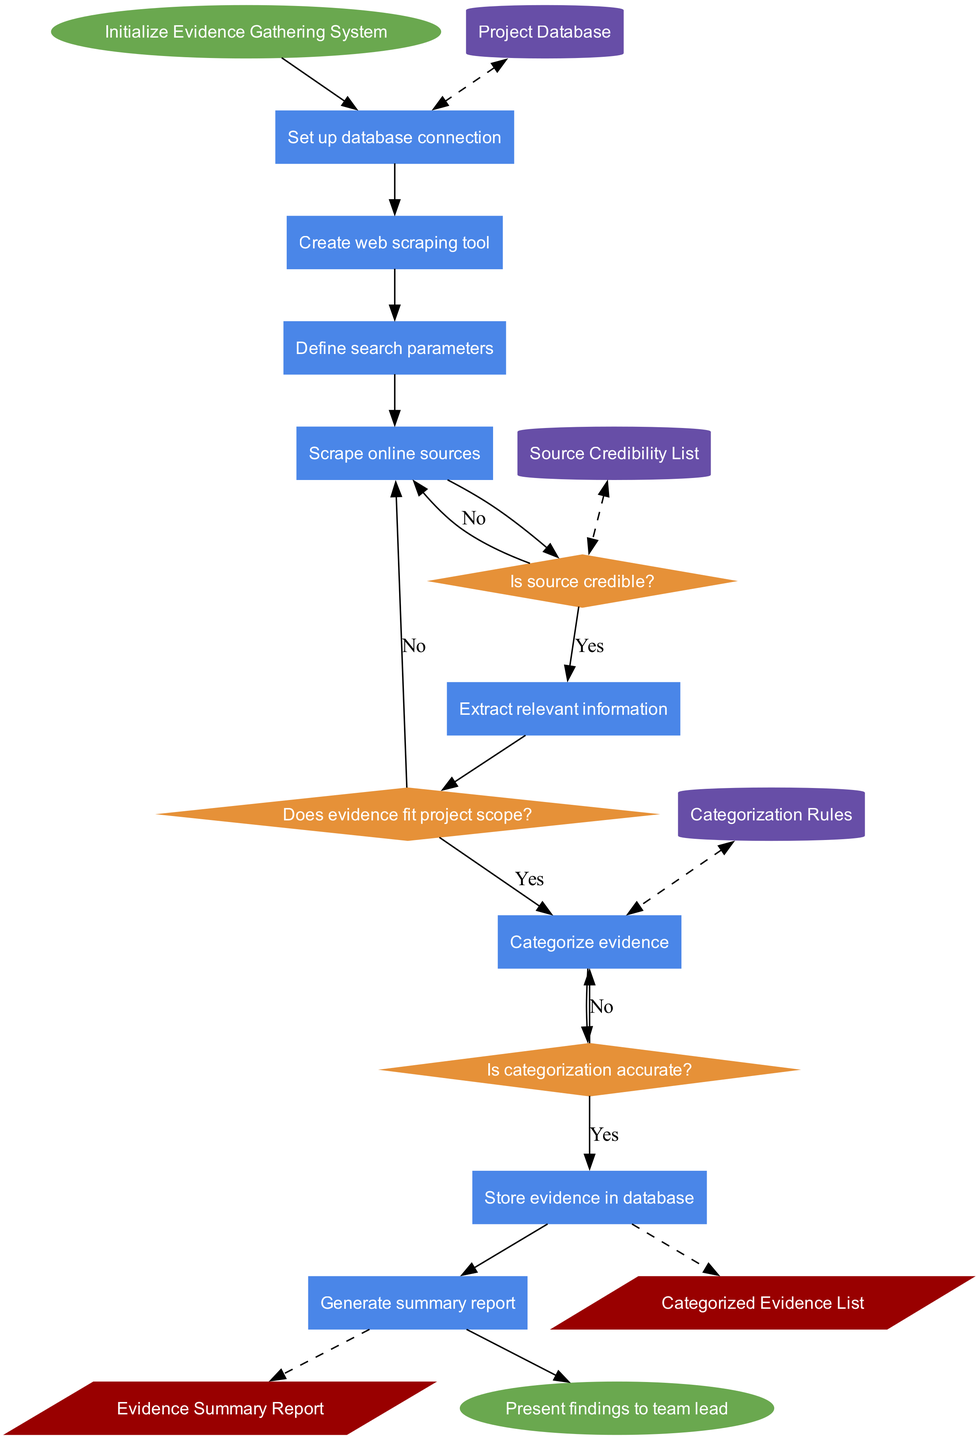What is the first process in the diagram? The flowchart starts with the "Set up database connection" process after the "Initialize Evidence Gathering System" node. This can be identified as it is the first node that follows the start node.
Answer: Set up database connection How many decision nodes are there in total? The diagram contains three decision nodes: "Is source credible?", "Does evidence fit project scope?", and "Is categorization accurate?". Counting these decision shapes in the flowchart gives us the total.
Answer: 3 What is the credibility check decision? The credibility check is represented by the decision node "Is source credible?", which asks if the source of the evidence is credible before proceeding. This is identified as a decision point in the flow.
Answer: Is source credible? Which data store is connected to the "Is source credible?" decision? The "Source Credibility List" data store is connected to the "Is source credible?" decision, as indicated by the dashed line connecting the data store to that decision shape. This means it provides information to the decision.
Answer: Source Credibility List What is the final output of the flowchart? The flowchart concludes with a final output of "Evidence Summary Report" after the last process "Generate summary report". This is derived from tracing the flow to the output node at the end of the diagram.
Answer: Evidence Summary Report What happens if the evidence does not fit the project scope? If the evidence does not fit the project scope, indicated by the "No" edge from the "Does evidence fit project scope?" decision node, the flow will return to the "Scrape online sources" process to try gathering more evidence.
Answer: Scrape online sources How many processes are involved in the flowchart? There are eight processes in the diagram consisting of "Set up database connection", "Create web scraping tool", "Define search parameters", "Scrape online sources", "Extract relevant information", "Categorize evidence", "Store evidence in database", and "Generate summary report". Counting each of these outlined steps gives the total number of processes.
Answer: 8 What is the decision made after extracting the relevant information? After extracting the relevant information, the decision made is "Does evidence fit project scope?". This is discerned by following the flow from the "Extract relevant information" process to the associated decision node.
Answer: Does evidence fit project scope? 